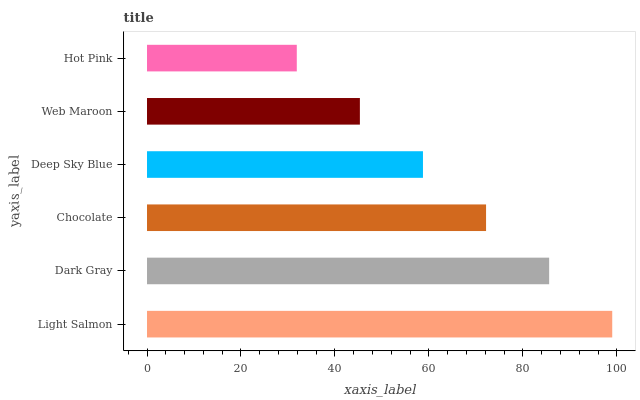Is Hot Pink the minimum?
Answer yes or no. Yes. Is Light Salmon the maximum?
Answer yes or no. Yes. Is Dark Gray the minimum?
Answer yes or no. No. Is Dark Gray the maximum?
Answer yes or no. No. Is Light Salmon greater than Dark Gray?
Answer yes or no. Yes. Is Dark Gray less than Light Salmon?
Answer yes or no. Yes. Is Dark Gray greater than Light Salmon?
Answer yes or no. No. Is Light Salmon less than Dark Gray?
Answer yes or no. No. Is Chocolate the high median?
Answer yes or no. Yes. Is Deep Sky Blue the low median?
Answer yes or no. Yes. Is Web Maroon the high median?
Answer yes or no. No. Is Web Maroon the low median?
Answer yes or no. No. 